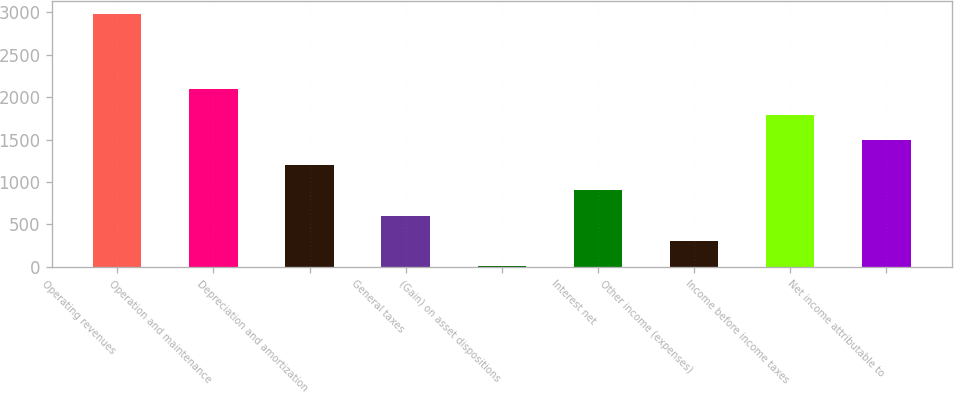Convert chart to OTSL. <chart><loc_0><loc_0><loc_500><loc_500><bar_chart><fcel>Operating revenues<fcel>Operation and maintenance<fcel>Depreciation and amortization<fcel>General taxes<fcel>(Gain) on asset dispositions<fcel>Interest net<fcel>Other income (expenses)<fcel>Income before income taxes<fcel>Net income attributable to<nl><fcel>2984<fcel>2090.9<fcel>1197.8<fcel>602.4<fcel>7<fcel>900.1<fcel>304.7<fcel>1793.2<fcel>1495.5<nl></chart> 